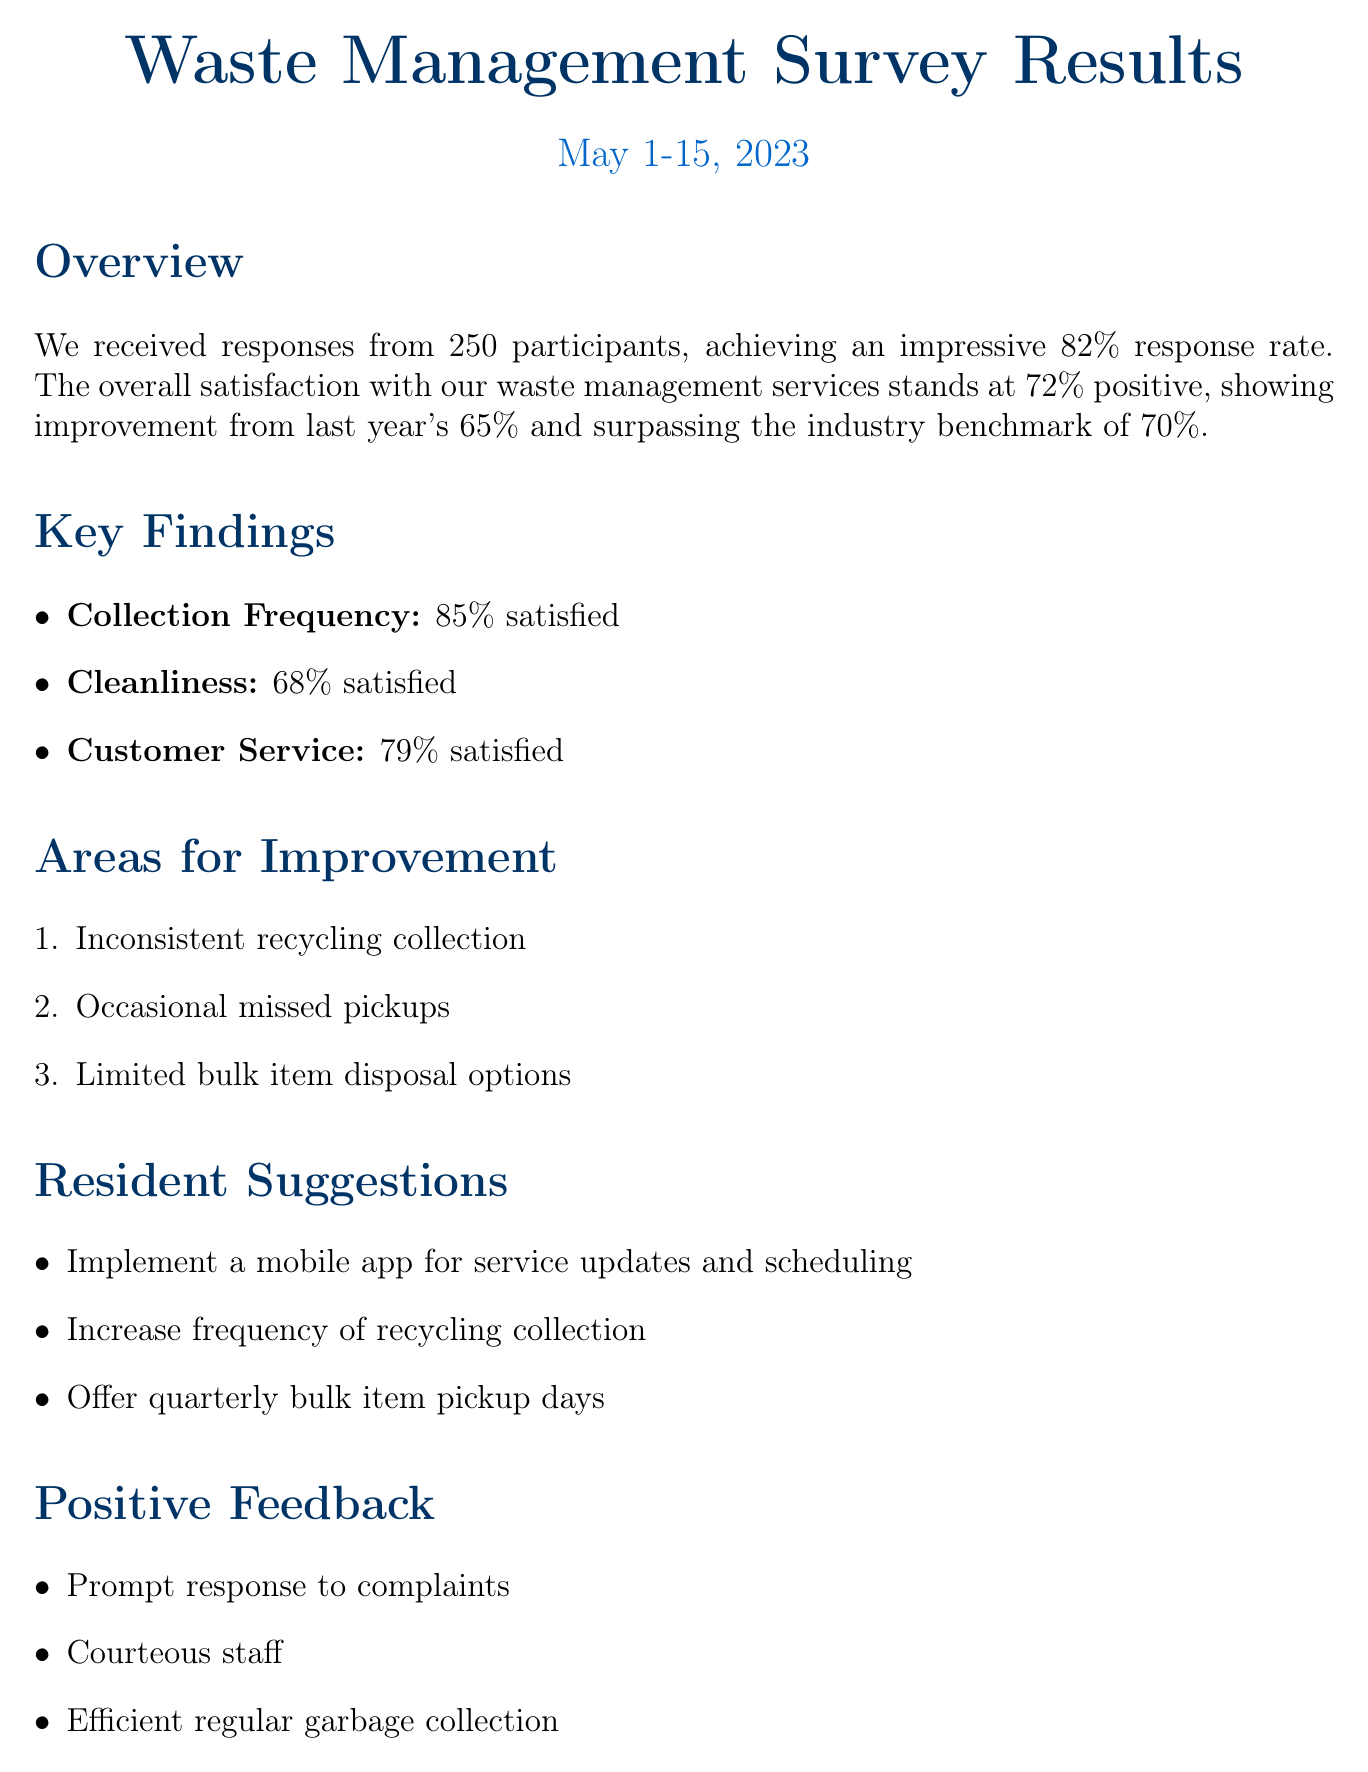What was the response rate of the survey? The response rate is given as a percentage of participants who responded to the survey.
Answer: 82% How many participants were involved in the survey? The number of participants is explicitly stated in the document.
Answer: 250 What percentage of residents were satisfied with the collection frequency? The satisfaction rate for collection frequency is mentioned under satisfaction ratings.
Answer: 85% satisfied What are the three key issues identified in the survey? The key issues are listed explicitly in the document, requiring enumeration.
Answer: Inconsistent recycling collection, Occasional missed pickups, Limited bulk item disposal options What is one suggested improvement for the waste management services? The document lists suggestions for improvement that residents provided.
Answer: Implement a mobile app for service updates and scheduling How does the current overall satisfaction compare to the previous year? This question requires reasoning about the satisfaction ratings from two different years as stated in the document.
Answer: Improved from 65% to 72% What was the overall satisfaction percentage reported in the survey? The document specifies the overall satisfaction percentage directly.
Answer: 72% positive What is the next step after reviewing the survey results? The subsequent step is detailed within the next steps section of the document.
Answer: Develop action plan to address key issues 